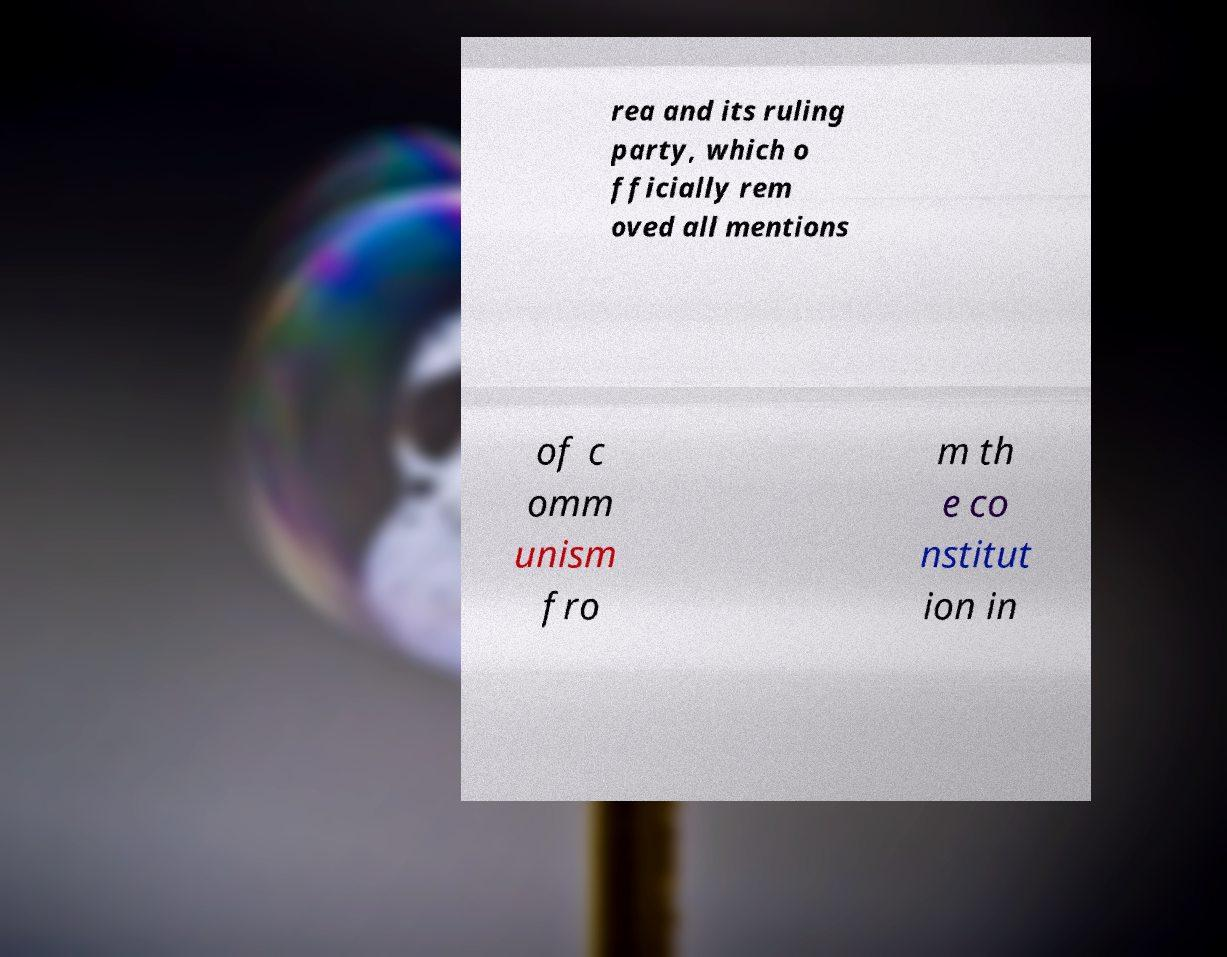There's text embedded in this image that I need extracted. Can you transcribe it verbatim? rea and its ruling party, which o fficially rem oved all mentions of c omm unism fro m th e co nstitut ion in 